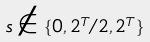Convert formula to latex. <formula><loc_0><loc_0><loc_500><loc_500>s \notin \{ 0 , 2 ^ { T } / 2 , 2 ^ { T } \}</formula> 